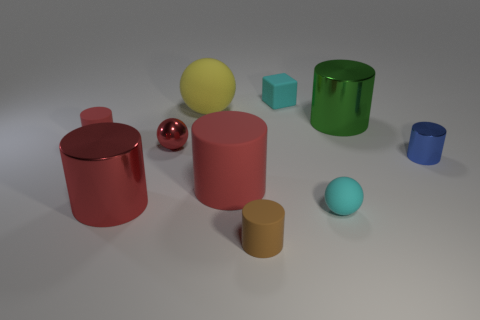What materials do the objects in the image appear to be made from? The objects in this image seem to have varying textures suggesting different materials. The cylinders and the smaller spheres have a matte finish that might indicate a rubber or plastic material, while the red, reflective sphere likely represents a polished metal. 